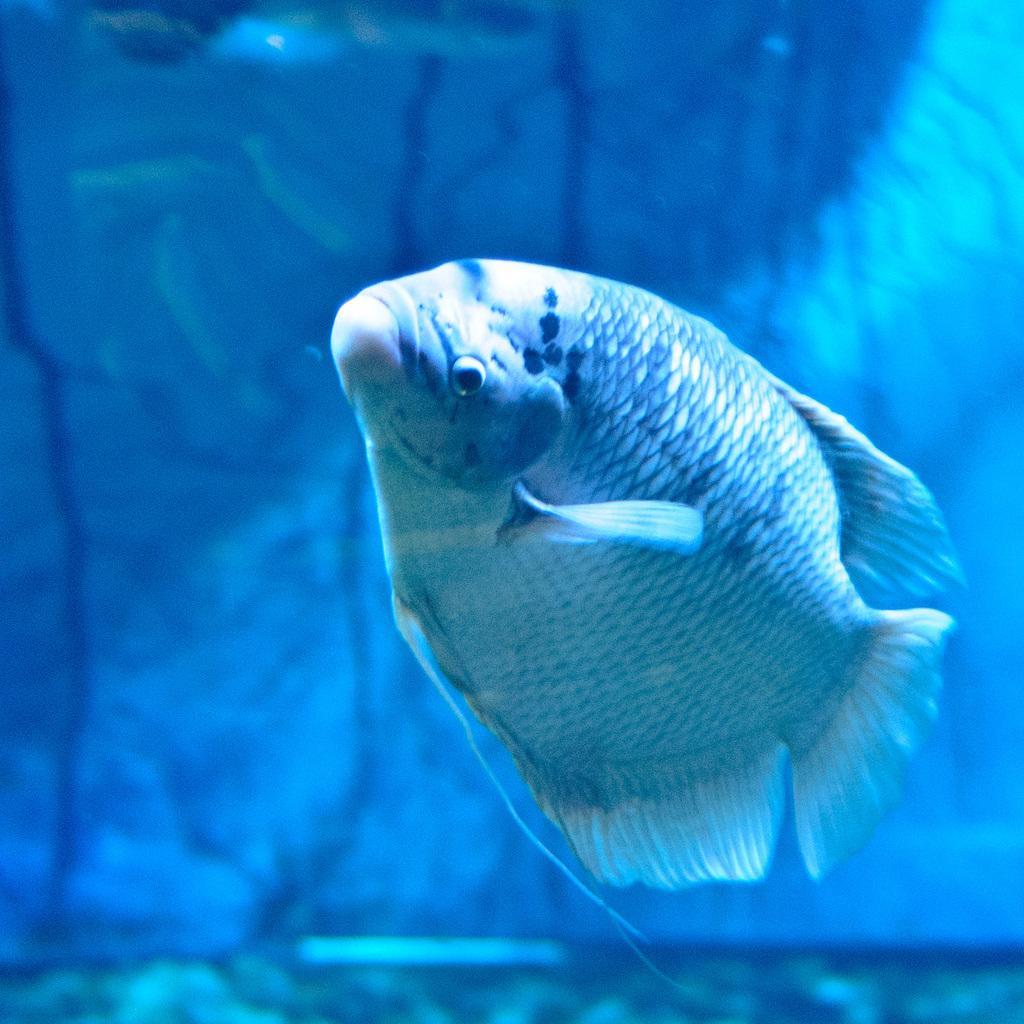What type of animal is in the image? There is a fish in the image. Where is the fish located? The fish is in the water. What is the weight of the fish in the image? The weight of the fish cannot be determined from the image alone, as it depends on the species and size of the fish. 